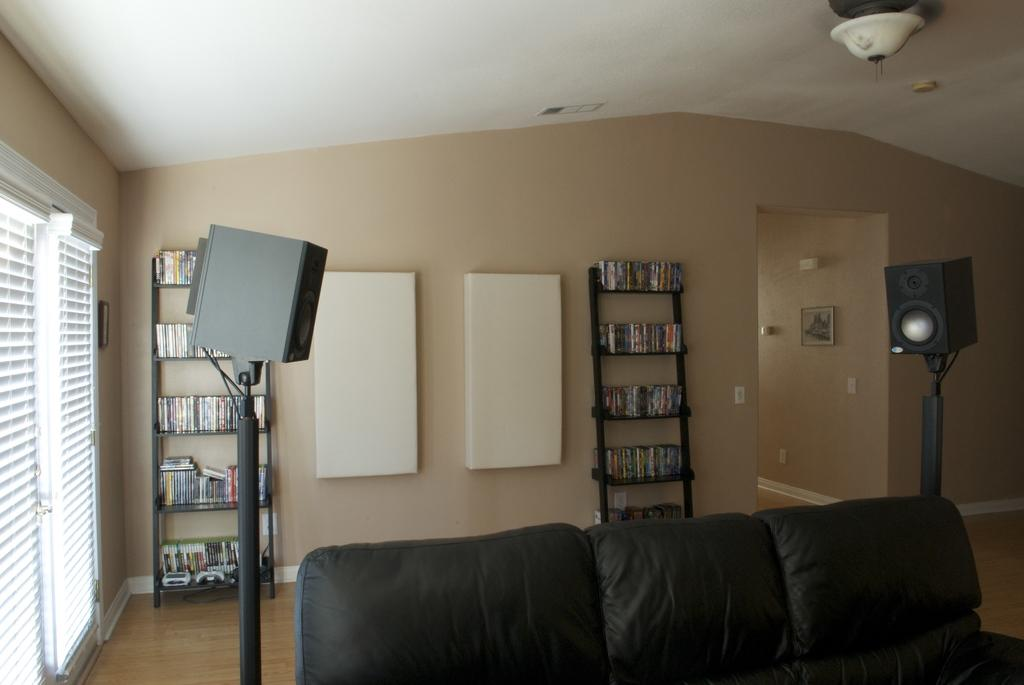What type of room is shown in the image? The image depicts a living room. What furniture is present in the living room? There is a sofa in the living room. What lighting fixture can be seen in the living room? There is a stand with a light in the living room. What type of storage is available in the living room? There is a shelf with books in the living room. How is the shelf secured in the living room? The shelf is attached to the wall. What type of stick is used for the battle scene in the living room? There is no battle scene or stick present in the living room; it is a typical living room with a sofa, light, and bookshelf. 